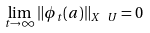Convert formula to latex. <formula><loc_0><loc_0><loc_500><loc_500>\lim _ { t \to \infty } \| \phi _ { t } ( a ) \| _ { X \ U } = 0</formula> 